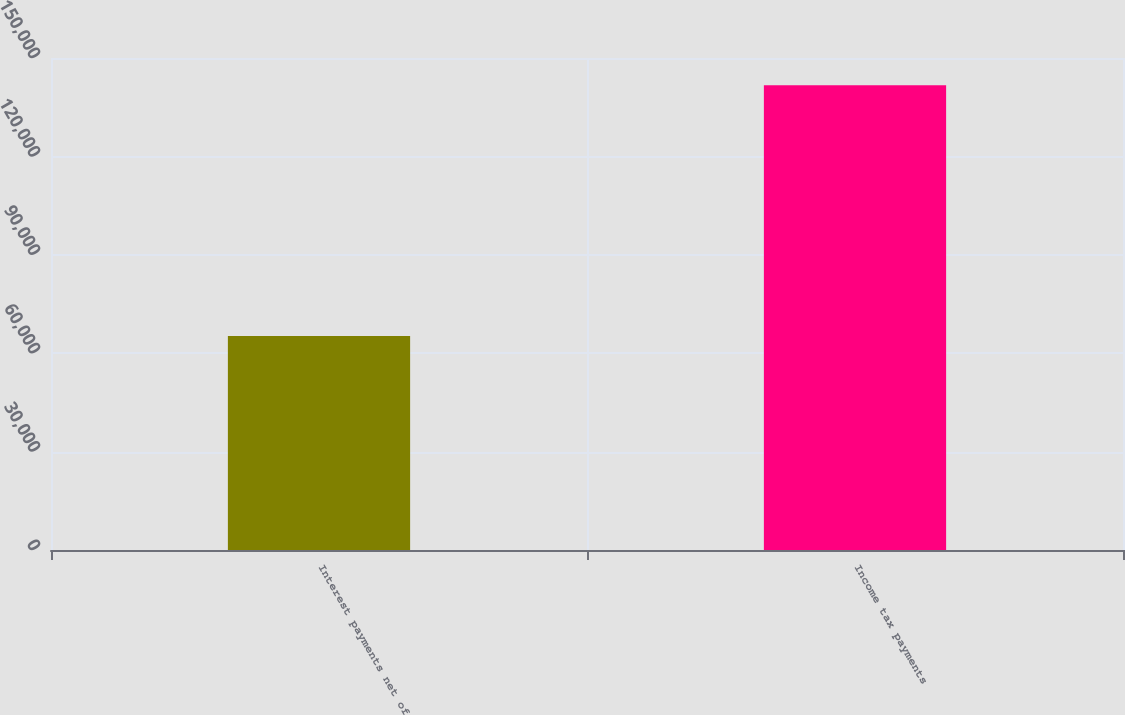Convert chart to OTSL. <chart><loc_0><loc_0><loc_500><loc_500><bar_chart><fcel>Interest payments net of<fcel>Income tax payments<nl><fcel>65225<fcel>141661<nl></chart> 